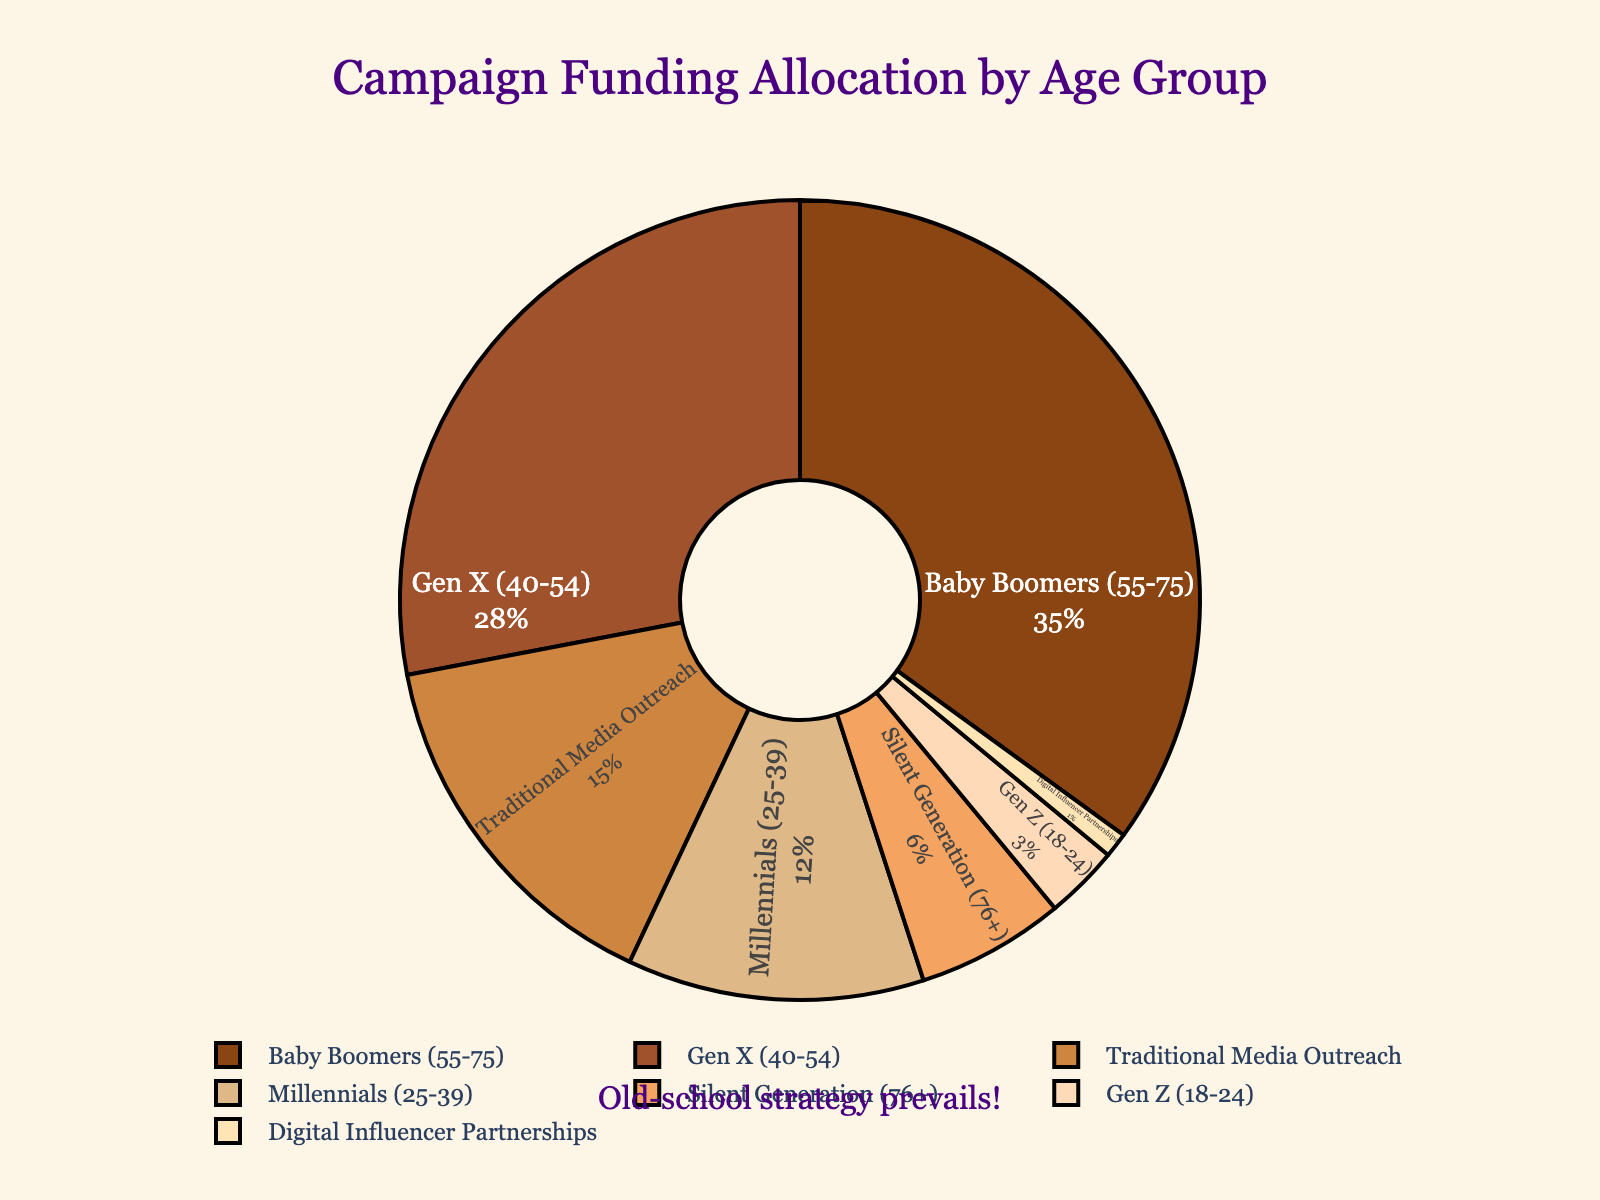What's the combined percentage for Baby Boomers and Gen X? The figure indicates that Baby Boomers have a percentage of 35% and Gen X has 28%. Summing these two percentages together: 35% + 28% = 63%.
Answer: 63% Which age group receives less campaign funding allocation, Millennials or the Silent Generation? By looking at the figure, Millennials receive 12% and the Silent Generation receives 6%. 12% is greater than 6%, so Silent Generation receives less.
Answer: Silent Generation What is the percentage difference between Gen X and Millennials? The figure shows that Gen X is allocated 28% and Millennials 12%. Subtracting 12% from 28%: 28% - 12% = 16%.
Answer: 16% Which group has the smallest percentage allocation? The figure indicates that Digital Influencer Partnerships have the smallest allocation with 1%.
Answer: Digital Influencer Partnerships Compare the allocation of Gen Z to Traditional Media Outreach. According to the figure, Gen Z has 3% while Traditional Media Outreach has 15%. 3% is less than 15%.
Answer: Gen Z has less allocation What percent does the combined allocation for Traditional Media Outreach and Digital Influencer Partnerships represent? The chart shows Traditional Media Outreach at 15% and Digital Influencer Partnerships at 1%. Adding these together: 15% + 1% = 16%.
Answer: 16% How much more percentage is allocated to Baby Boomers than to Millennials? The figure shows 35% for Baby Boomers and 12% for Millennials. Subtracting the two: 35% - 12% = 23%.
Answer: 23% Is the allocation for Gen Z more than the Silent Generation? Referring to the chart, Gen Z has 3% and the Silent Generation 6%. 3% is not more than 6%.
Answer: No What is the total percentage of all groups combined? The sum of all percentages in the chart would be: 35% + 28% + 15% + 12% + 6% + 3% + 1% = 100%.
Answer: 100% 